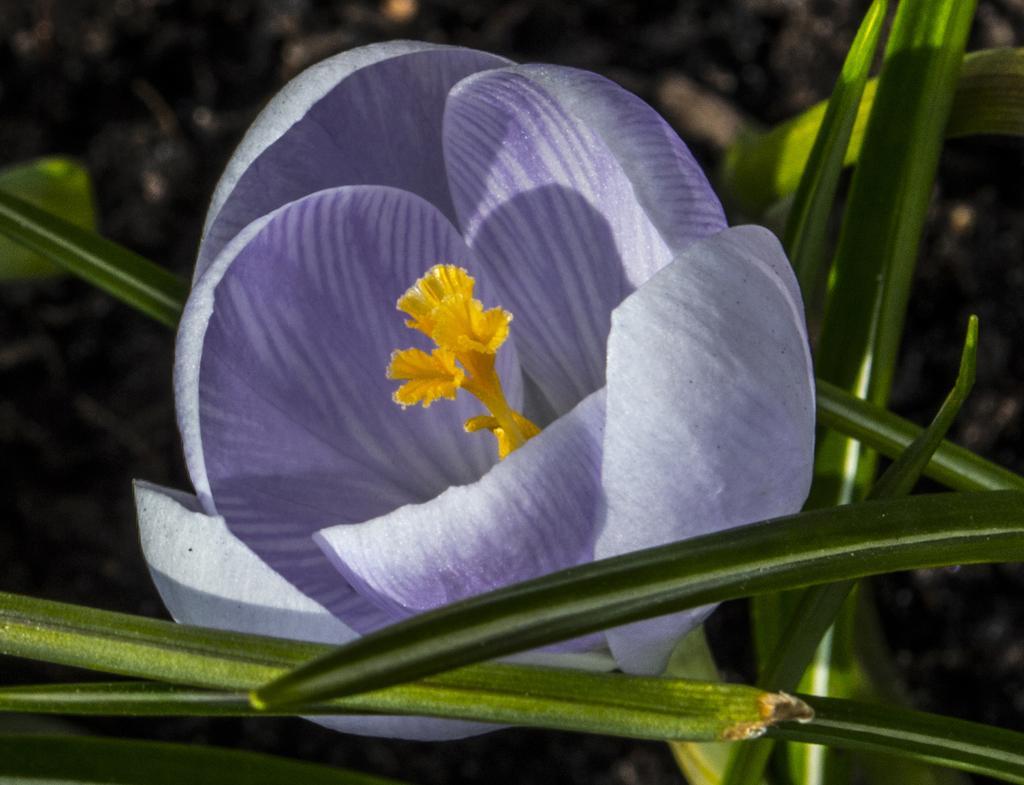Can you describe this image briefly? In this picture there is a light purple color flower on the plant. At the back it looks like mud. 